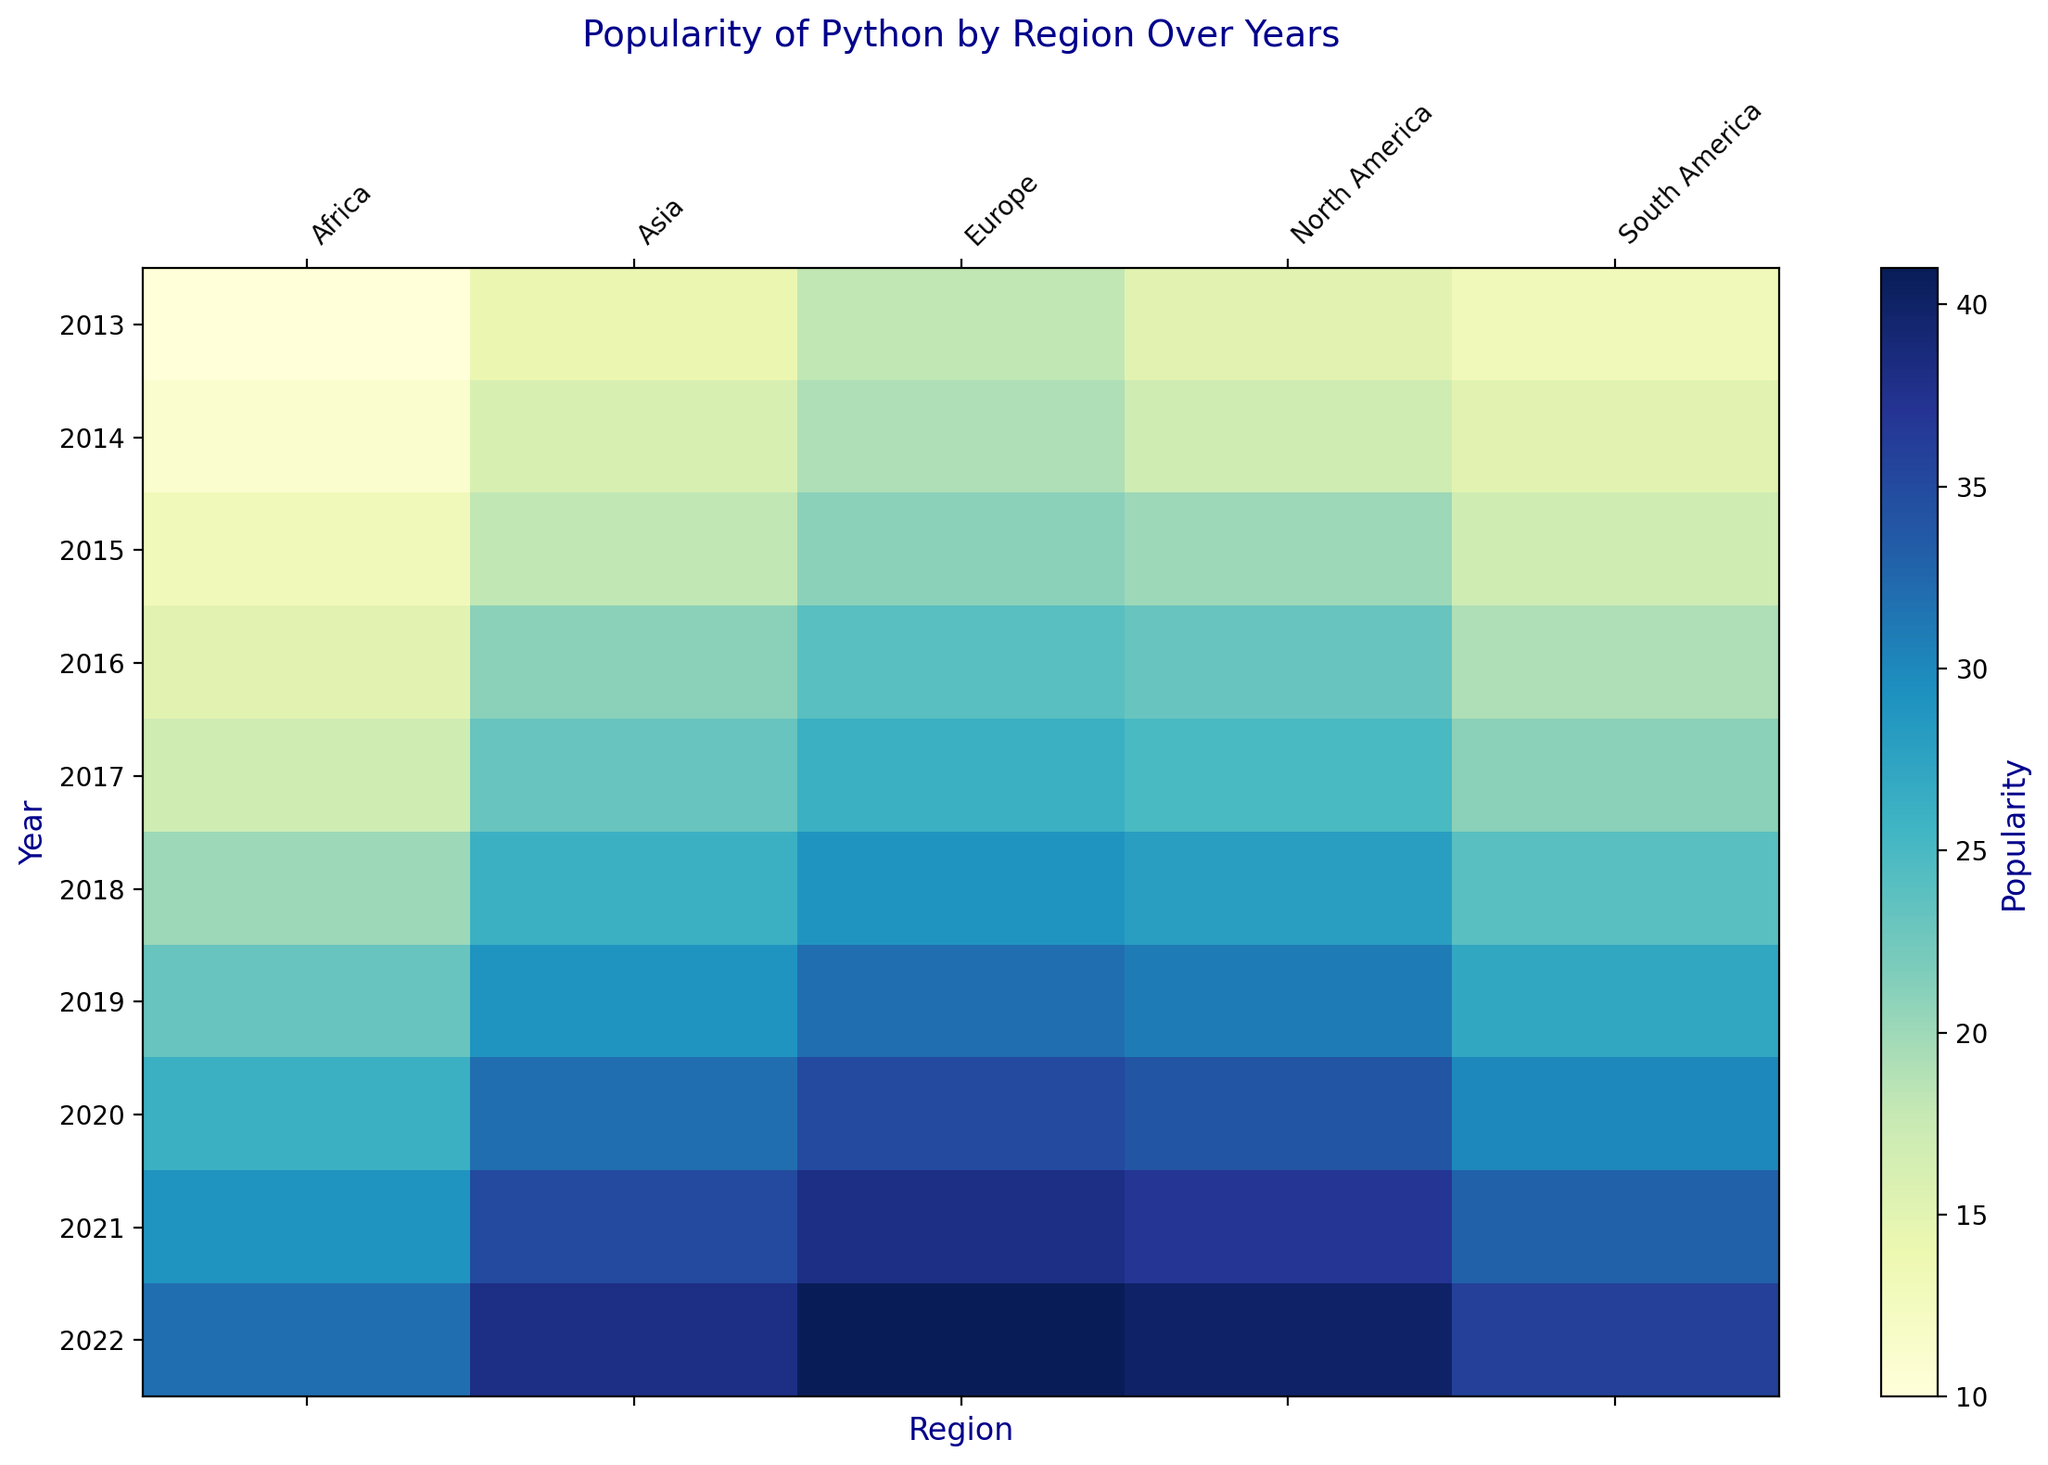What year did Python's popularity surpass 20 in all regions? By examining the trend from year to year for each region, it can be seen that Python's popularity reaches or exceeds 20 in all regions starting from the year 2017.
Answer: 2017 Which region had the highest increase in Python popularity from 2014 to 2020? To determine the region with the highest increase, subtract the 2014 value from the 2020 value for each region and compare the results. North America had an increase from 17 to 34. Europe increased from 19 to 35. Asia increased from 16 to 32. South America increased from 15 to 30. Africa increased from 11 to 26. The highest increase is 18 in Europe.
Answer: Europe What is the general trend of Python popularity in North America from 2013 to 2022? By observing the color gradients and numerical values over the years for North America, it becomes clear that Python's popularity increases consistently from 15 to 40 over the period.
Answer: Consistently increasing How does Python's popularity in Asia in 2022 compare to that in Europe in 2015? Python's popularity in Asia in 2022 is 38, and in Europe in 2015, it is 21. Therefore, Python's popularity in Asia in 2022 is higher.
Answer: Higher Which region showed the most consistent growth in Python popularity over the entire period? By examining the values and color gradients from 2013 to 2022 for each region, Europe, which shows incremental increases almost every year with no decreases, appears to display the most consistent growth.
Answer: Europe What is the average popularity of Python across all regions in the year 2019? Sum the values of Python popularity for each region in 2019 and divide by the number of regions: (31 + 32 + 29 + 27 + 23) / 5 = 142 / 5 = 28.4
Answer: 28.4 In which year did Africa’s Python popularity first exceed 20? By looking through the years for Africa, Python's popularity exceeds 20 in 2020 for the first time.
Answer: 2020 Between 2016 and 2022, which region had the smallest total increase in Python popularity? Subtract the 2016 values from the 2022 values for each region and find the smallest difference. North America increased from 23 to 40 (+17), Europe from 24 to 41 (+17), Asia from 21 to 38 (+17), South America from 19 to 36 (+17), and Africa from 15 to 32 (+17). In this case, all regions had the same increase.
Answer: All the same What is the difference in Python popularity between North America and Africa in 2021? In 2021, Python's popularity is 37 in North America and 29 in Africa. The difference is 37 - 29 = 8.
Answer: 8 Which region had the highest Python popularity in 2018, and what was the value? By locating the year 2018 and comparing the values across all regions, Europe has the highest value of 29.
Answer: Europe, 29 